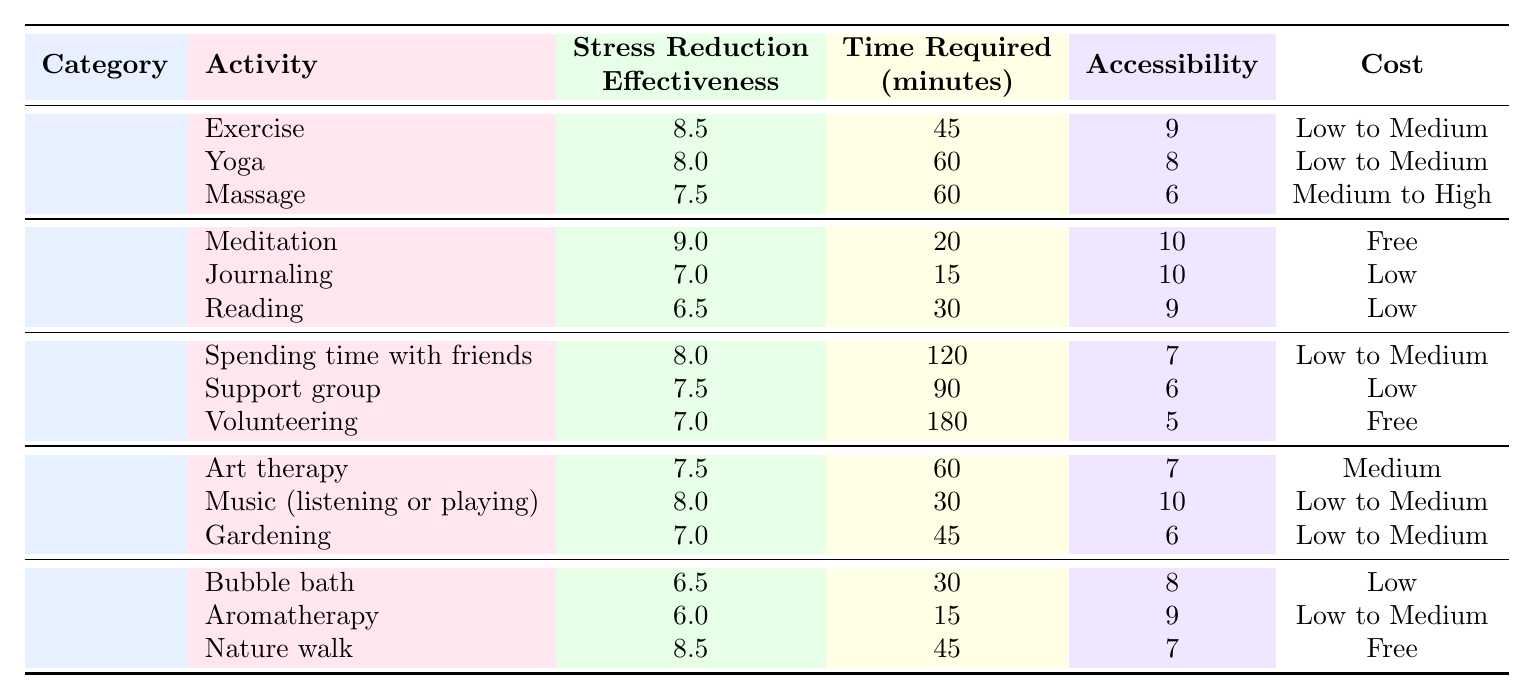What is the most effective self-care activity for stress reduction? The self-care activity with the highest stress reduction effectiveness is "Meditation," which scores 9.0.
Answer: Meditation How much time does "Spending time with friends" require? This activity requires 120 minutes, as shown in the table under the time required column.
Answer: 120 minutes Which self-care activity has the highest cost? "Massage" has the highest cost categorization, which is "Medium to High."
Answer: Medium to High What is the average stress reduction effectiveness of the "Creative" category? To find the average, we sum the effectiveness scores (7.5 + 8.0 + 7.0 = 22.5) and divide by the number of activities (3), resulting in 22.5 / 3 = 7.5.
Answer: 7.5 Is "Nature walk" more effective than "Bubble bath"? Yes, "Nature walk" has a stress reduction effectiveness of 8.5, while "Bubble bath" has a score of 6.5, making nature walks more effective.
Answer: Yes Which activity requires the least time in the "Mental" category? The activity "Journaling" requires only 15 minutes, which is less than the other mental activities listed.
Answer: 15 minutes If I want to reduce stress and have only 30 minutes, which activities would be suitable? Based on the table, the suitable activities are "Music (listening or playing)" (30 minutes) and "Bubble bath" (30 minutes). Both fit within the 30-minute timeframe.
Answer: Music (listening or playing), Bubble bath Which category has the lowest average accessibility score? The "Social" category has the lowest accessibility score with an average of (7 + 6 + 5) / 3 = 6.0.
Answer: Social Is there a self-care activity listed that is free? Yes, both "Meditation" and "Volunteering" are free activities according to the cost column in the table.
Answer: Yes What is the difference in stress reduction effectiveness between "Aromatherapy" and "Yoga"? "Aromatherapy" has an effectiveness of 6.0 while "Yoga" has an effectiveness of 8.0, so the difference is 8.0 - 6.0 = 2.0.
Answer: 2.0 